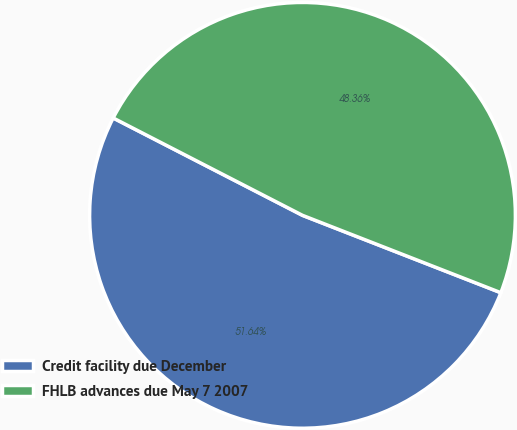<chart> <loc_0><loc_0><loc_500><loc_500><pie_chart><fcel>Credit facility due December<fcel>FHLB advances due May 7 2007<nl><fcel>51.64%<fcel>48.36%<nl></chart> 